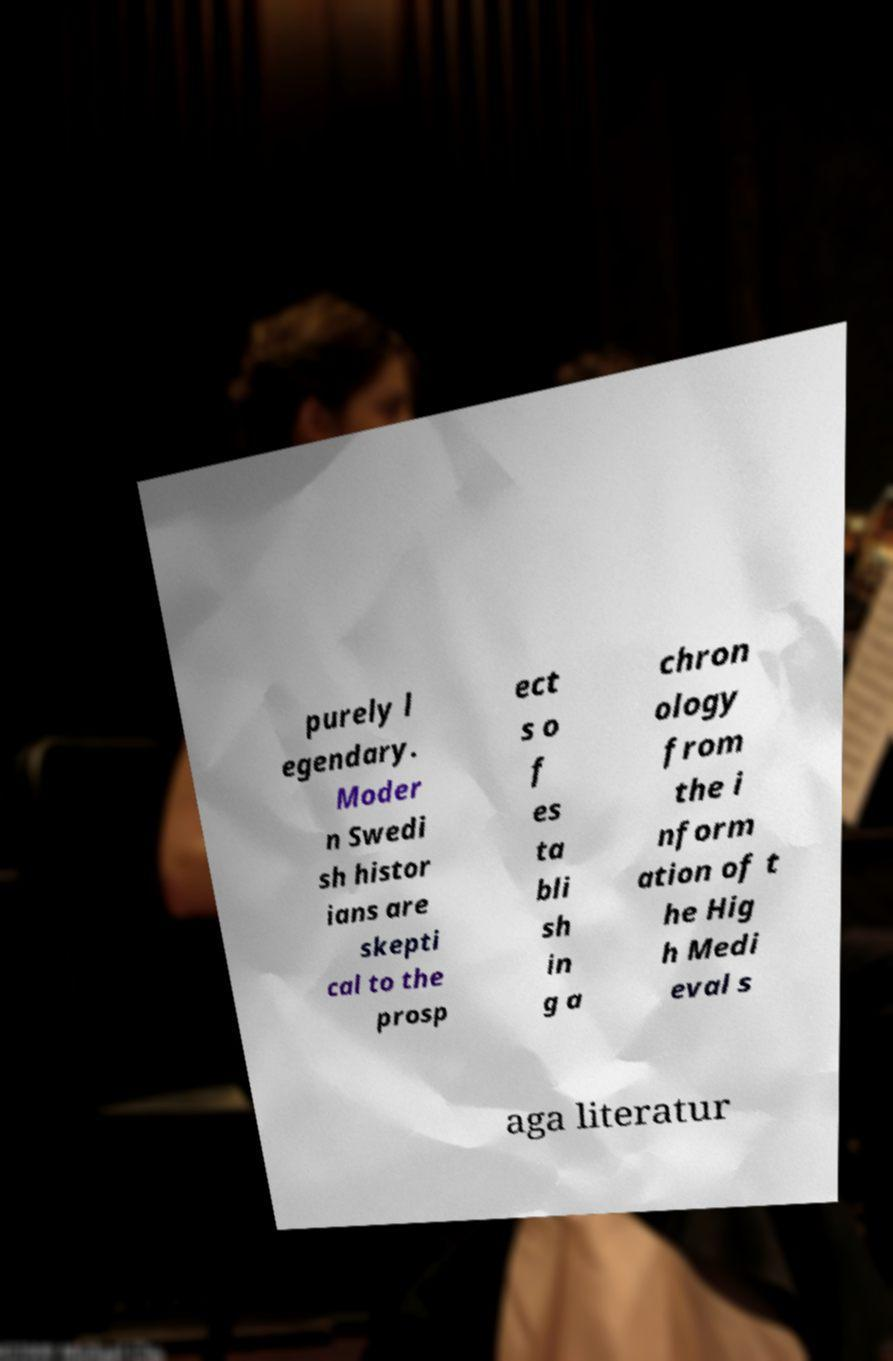Please read and relay the text visible in this image. What does it say? purely l egendary. Moder n Swedi sh histor ians are skepti cal to the prosp ect s o f es ta bli sh in g a chron ology from the i nform ation of t he Hig h Medi eval s aga literatur 